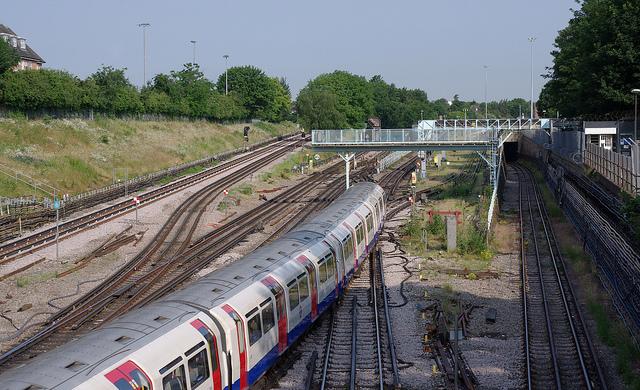Are the tracks busy?
Concise answer only. Yes. Is it a clear day?
Write a very short answer. Yes. What color is the train?
Answer briefly. Silver. 